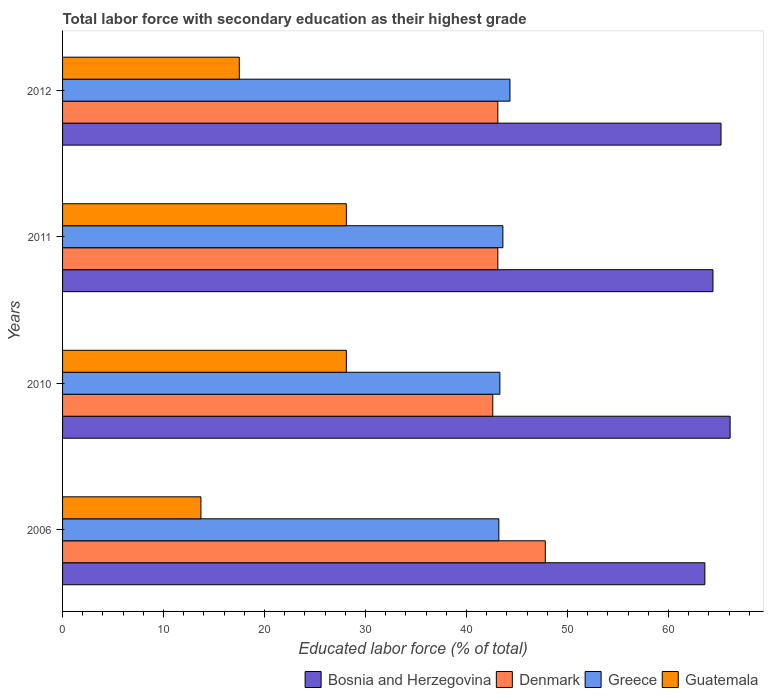How many different coloured bars are there?
Offer a very short reply. 4. How many groups of bars are there?
Offer a terse response. 4. Are the number of bars on each tick of the Y-axis equal?
Your answer should be very brief. Yes. How many bars are there on the 4th tick from the top?
Keep it short and to the point. 4. What is the label of the 4th group of bars from the top?
Make the answer very short. 2006. In how many cases, is the number of bars for a given year not equal to the number of legend labels?
Offer a very short reply. 0. What is the percentage of total labor force with primary education in Denmark in 2006?
Make the answer very short. 47.8. Across all years, what is the maximum percentage of total labor force with primary education in Bosnia and Herzegovina?
Your answer should be compact. 66.1. Across all years, what is the minimum percentage of total labor force with primary education in Denmark?
Give a very brief answer. 42.6. What is the total percentage of total labor force with primary education in Bosnia and Herzegovina in the graph?
Your answer should be very brief. 259.3. What is the difference between the percentage of total labor force with primary education in Greece in 2010 and that in 2012?
Make the answer very short. -1. What is the difference between the percentage of total labor force with primary education in Bosnia and Herzegovina in 2011 and the percentage of total labor force with primary education in Greece in 2012?
Give a very brief answer. 20.1. What is the average percentage of total labor force with primary education in Greece per year?
Your response must be concise. 43.6. In the year 2011, what is the difference between the percentage of total labor force with primary education in Denmark and percentage of total labor force with primary education in Bosnia and Herzegovina?
Provide a short and direct response. -21.3. In how many years, is the percentage of total labor force with primary education in Denmark greater than 10 %?
Your answer should be compact. 4. What is the ratio of the percentage of total labor force with primary education in Denmark in 2006 to that in 2011?
Your response must be concise. 1.11. Is the difference between the percentage of total labor force with primary education in Denmark in 2006 and 2012 greater than the difference between the percentage of total labor force with primary education in Bosnia and Herzegovina in 2006 and 2012?
Provide a short and direct response. Yes. What is the difference between the highest and the lowest percentage of total labor force with primary education in Bosnia and Herzegovina?
Offer a terse response. 2.5. Is the sum of the percentage of total labor force with primary education in Denmark in 2006 and 2010 greater than the maximum percentage of total labor force with primary education in Greece across all years?
Give a very brief answer. Yes. Is it the case that in every year, the sum of the percentage of total labor force with primary education in Guatemala and percentage of total labor force with primary education in Bosnia and Herzegovina is greater than the sum of percentage of total labor force with primary education in Denmark and percentage of total labor force with primary education in Greece?
Offer a very short reply. No. What does the 3rd bar from the top in 2006 represents?
Ensure brevity in your answer.  Denmark. What does the 3rd bar from the bottom in 2006 represents?
Ensure brevity in your answer.  Greece. What is the difference between two consecutive major ticks on the X-axis?
Make the answer very short. 10. Are the values on the major ticks of X-axis written in scientific E-notation?
Provide a succinct answer. No. Does the graph contain any zero values?
Give a very brief answer. No. How many legend labels are there?
Your response must be concise. 4. How are the legend labels stacked?
Make the answer very short. Horizontal. What is the title of the graph?
Make the answer very short. Total labor force with secondary education as their highest grade. Does "Nepal" appear as one of the legend labels in the graph?
Your answer should be compact. No. What is the label or title of the X-axis?
Provide a short and direct response. Educated labor force (% of total). What is the label or title of the Y-axis?
Your answer should be very brief. Years. What is the Educated labor force (% of total) in Bosnia and Herzegovina in 2006?
Give a very brief answer. 63.6. What is the Educated labor force (% of total) in Denmark in 2006?
Offer a very short reply. 47.8. What is the Educated labor force (% of total) of Greece in 2006?
Offer a very short reply. 43.2. What is the Educated labor force (% of total) in Guatemala in 2006?
Give a very brief answer. 13.7. What is the Educated labor force (% of total) of Bosnia and Herzegovina in 2010?
Offer a very short reply. 66.1. What is the Educated labor force (% of total) in Denmark in 2010?
Provide a short and direct response. 42.6. What is the Educated labor force (% of total) in Greece in 2010?
Make the answer very short. 43.3. What is the Educated labor force (% of total) of Guatemala in 2010?
Offer a terse response. 28.1. What is the Educated labor force (% of total) of Bosnia and Herzegovina in 2011?
Your response must be concise. 64.4. What is the Educated labor force (% of total) in Denmark in 2011?
Make the answer very short. 43.1. What is the Educated labor force (% of total) in Greece in 2011?
Your response must be concise. 43.6. What is the Educated labor force (% of total) in Guatemala in 2011?
Make the answer very short. 28.1. What is the Educated labor force (% of total) of Bosnia and Herzegovina in 2012?
Ensure brevity in your answer.  65.2. What is the Educated labor force (% of total) in Denmark in 2012?
Keep it short and to the point. 43.1. What is the Educated labor force (% of total) of Greece in 2012?
Make the answer very short. 44.3. Across all years, what is the maximum Educated labor force (% of total) of Bosnia and Herzegovina?
Make the answer very short. 66.1. Across all years, what is the maximum Educated labor force (% of total) of Denmark?
Your answer should be compact. 47.8. Across all years, what is the maximum Educated labor force (% of total) of Greece?
Offer a terse response. 44.3. Across all years, what is the maximum Educated labor force (% of total) of Guatemala?
Provide a succinct answer. 28.1. Across all years, what is the minimum Educated labor force (% of total) of Bosnia and Herzegovina?
Your response must be concise. 63.6. Across all years, what is the minimum Educated labor force (% of total) of Denmark?
Offer a very short reply. 42.6. Across all years, what is the minimum Educated labor force (% of total) of Greece?
Give a very brief answer. 43.2. Across all years, what is the minimum Educated labor force (% of total) in Guatemala?
Offer a terse response. 13.7. What is the total Educated labor force (% of total) in Bosnia and Herzegovina in the graph?
Keep it short and to the point. 259.3. What is the total Educated labor force (% of total) in Denmark in the graph?
Offer a terse response. 176.6. What is the total Educated labor force (% of total) in Greece in the graph?
Provide a succinct answer. 174.4. What is the total Educated labor force (% of total) in Guatemala in the graph?
Make the answer very short. 87.4. What is the difference between the Educated labor force (% of total) of Bosnia and Herzegovina in 2006 and that in 2010?
Your response must be concise. -2.5. What is the difference between the Educated labor force (% of total) of Greece in 2006 and that in 2010?
Provide a short and direct response. -0.1. What is the difference between the Educated labor force (% of total) in Guatemala in 2006 and that in 2010?
Make the answer very short. -14.4. What is the difference between the Educated labor force (% of total) in Denmark in 2006 and that in 2011?
Ensure brevity in your answer.  4.7. What is the difference between the Educated labor force (% of total) of Greece in 2006 and that in 2011?
Your answer should be compact. -0.4. What is the difference between the Educated labor force (% of total) in Guatemala in 2006 and that in 2011?
Provide a short and direct response. -14.4. What is the difference between the Educated labor force (% of total) in Greece in 2006 and that in 2012?
Your answer should be compact. -1.1. What is the difference between the Educated labor force (% of total) of Bosnia and Herzegovina in 2010 and that in 2011?
Offer a very short reply. 1.7. What is the difference between the Educated labor force (% of total) in Denmark in 2010 and that in 2011?
Provide a succinct answer. -0.5. What is the difference between the Educated labor force (% of total) in Bosnia and Herzegovina in 2010 and that in 2012?
Keep it short and to the point. 0.9. What is the difference between the Educated labor force (% of total) in Denmark in 2010 and that in 2012?
Make the answer very short. -0.5. What is the difference between the Educated labor force (% of total) of Guatemala in 2011 and that in 2012?
Your answer should be compact. 10.6. What is the difference between the Educated labor force (% of total) of Bosnia and Herzegovina in 2006 and the Educated labor force (% of total) of Greece in 2010?
Offer a very short reply. 20.3. What is the difference between the Educated labor force (% of total) of Bosnia and Herzegovina in 2006 and the Educated labor force (% of total) of Guatemala in 2010?
Ensure brevity in your answer.  35.5. What is the difference between the Educated labor force (% of total) in Denmark in 2006 and the Educated labor force (% of total) in Greece in 2010?
Give a very brief answer. 4.5. What is the difference between the Educated labor force (% of total) in Denmark in 2006 and the Educated labor force (% of total) in Guatemala in 2010?
Give a very brief answer. 19.7. What is the difference between the Educated labor force (% of total) of Greece in 2006 and the Educated labor force (% of total) of Guatemala in 2010?
Your answer should be very brief. 15.1. What is the difference between the Educated labor force (% of total) of Bosnia and Herzegovina in 2006 and the Educated labor force (% of total) of Denmark in 2011?
Your answer should be compact. 20.5. What is the difference between the Educated labor force (% of total) of Bosnia and Herzegovina in 2006 and the Educated labor force (% of total) of Guatemala in 2011?
Your answer should be compact. 35.5. What is the difference between the Educated labor force (% of total) of Bosnia and Herzegovina in 2006 and the Educated labor force (% of total) of Denmark in 2012?
Offer a terse response. 20.5. What is the difference between the Educated labor force (% of total) of Bosnia and Herzegovina in 2006 and the Educated labor force (% of total) of Greece in 2012?
Keep it short and to the point. 19.3. What is the difference between the Educated labor force (% of total) in Bosnia and Herzegovina in 2006 and the Educated labor force (% of total) in Guatemala in 2012?
Provide a short and direct response. 46.1. What is the difference between the Educated labor force (% of total) in Denmark in 2006 and the Educated labor force (% of total) in Greece in 2012?
Make the answer very short. 3.5. What is the difference between the Educated labor force (% of total) of Denmark in 2006 and the Educated labor force (% of total) of Guatemala in 2012?
Make the answer very short. 30.3. What is the difference between the Educated labor force (% of total) in Greece in 2006 and the Educated labor force (% of total) in Guatemala in 2012?
Keep it short and to the point. 25.7. What is the difference between the Educated labor force (% of total) in Bosnia and Herzegovina in 2010 and the Educated labor force (% of total) in Denmark in 2011?
Provide a succinct answer. 23. What is the difference between the Educated labor force (% of total) of Bosnia and Herzegovina in 2010 and the Educated labor force (% of total) of Greece in 2011?
Provide a succinct answer. 22.5. What is the difference between the Educated labor force (% of total) of Bosnia and Herzegovina in 2010 and the Educated labor force (% of total) of Greece in 2012?
Your answer should be very brief. 21.8. What is the difference between the Educated labor force (% of total) in Bosnia and Herzegovina in 2010 and the Educated labor force (% of total) in Guatemala in 2012?
Provide a short and direct response. 48.6. What is the difference between the Educated labor force (% of total) in Denmark in 2010 and the Educated labor force (% of total) in Greece in 2012?
Your answer should be very brief. -1.7. What is the difference between the Educated labor force (% of total) of Denmark in 2010 and the Educated labor force (% of total) of Guatemala in 2012?
Keep it short and to the point. 25.1. What is the difference between the Educated labor force (% of total) in Greece in 2010 and the Educated labor force (% of total) in Guatemala in 2012?
Offer a very short reply. 25.8. What is the difference between the Educated labor force (% of total) of Bosnia and Herzegovina in 2011 and the Educated labor force (% of total) of Denmark in 2012?
Provide a short and direct response. 21.3. What is the difference between the Educated labor force (% of total) of Bosnia and Herzegovina in 2011 and the Educated labor force (% of total) of Greece in 2012?
Give a very brief answer. 20.1. What is the difference between the Educated labor force (% of total) in Bosnia and Herzegovina in 2011 and the Educated labor force (% of total) in Guatemala in 2012?
Make the answer very short. 46.9. What is the difference between the Educated labor force (% of total) in Denmark in 2011 and the Educated labor force (% of total) in Greece in 2012?
Keep it short and to the point. -1.2. What is the difference between the Educated labor force (% of total) of Denmark in 2011 and the Educated labor force (% of total) of Guatemala in 2012?
Make the answer very short. 25.6. What is the difference between the Educated labor force (% of total) of Greece in 2011 and the Educated labor force (% of total) of Guatemala in 2012?
Offer a terse response. 26.1. What is the average Educated labor force (% of total) in Bosnia and Herzegovina per year?
Ensure brevity in your answer.  64.83. What is the average Educated labor force (% of total) of Denmark per year?
Provide a succinct answer. 44.15. What is the average Educated labor force (% of total) in Greece per year?
Provide a succinct answer. 43.6. What is the average Educated labor force (% of total) in Guatemala per year?
Ensure brevity in your answer.  21.85. In the year 2006, what is the difference between the Educated labor force (% of total) of Bosnia and Herzegovina and Educated labor force (% of total) of Denmark?
Give a very brief answer. 15.8. In the year 2006, what is the difference between the Educated labor force (% of total) of Bosnia and Herzegovina and Educated labor force (% of total) of Greece?
Keep it short and to the point. 20.4. In the year 2006, what is the difference between the Educated labor force (% of total) of Bosnia and Herzegovina and Educated labor force (% of total) of Guatemala?
Give a very brief answer. 49.9. In the year 2006, what is the difference between the Educated labor force (% of total) in Denmark and Educated labor force (% of total) in Guatemala?
Make the answer very short. 34.1. In the year 2006, what is the difference between the Educated labor force (% of total) in Greece and Educated labor force (% of total) in Guatemala?
Ensure brevity in your answer.  29.5. In the year 2010, what is the difference between the Educated labor force (% of total) of Bosnia and Herzegovina and Educated labor force (% of total) of Greece?
Provide a short and direct response. 22.8. In the year 2010, what is the difference between the Educated labor force (% of total) of Bosnia and Herzegovina and Educated labor force (% of total) of Guatemala?
Keep it short and to the point. 38. In the year 2010, what is the difference between the Educated labor force (% of total) of Denmark and Educated labor force (% of total) of Greece?
Keep it short and to the point. -0.7. In the year 2010, what is the difference between the Educated labor force (% of total) in Greece and Educated labor force (% of total) in Guatemala?
Provide a short and direct response. 15.2. In the year 2011, what is the difference between the Educated labor force (% of total) of Bosnia and Herzegovina and Educated labor force (% of total) of Denmark?
Your answer should be compact. 21.3. In the year 2011, what is the difference between the Educated labor force (% of total) of Bosnia and Herzegovina and Educated labor force (% of total) of Greece?
Give a very brief answer. 20.8. In the year 2011, what is the difference between the Educated labor force (% of total) in Bosnia and Herzegovina and Educated labor force (% of total) in Guatemala?
Your answer should be compact. 36.3. In the year 2012, what is the difference between the Educated labor force (% of total) of Bosnia and Herzegovina and Educated labor force (% of total) of Denmark?
Ensure brevity in your answer.  22.1. In the year 2012, what is the difference between the Educated labor force (% of total) of Bosnia and Herzegovina and Educated labor force (% of total) of Greece?
Keep it short and to the point. 20.9. In the year 2012, what is the difference between the Educated labor force (% of total) in Bosnia and Herzegovina and Educated labor force (% of total) in Guatemala?
Your answer should be very brief. 47.7. In the year 2012, what is the difference between the Educated labor force (% of total) of Denmark and Educated labor force (% of total) of Greece?
Your answer should be very brief. -1.2. In the year 2012, what is the difference between the Educated labor force (% of total) in Denmark and Educated labor force (% of total) in Guatemala?
Provide a succinct answer. 25.6. In the year 2012, what is the difference between the Educated labor force (% of total) in Greece and Educated labor force (% of total) in Guatemala?
Give a very brief answer. 26.8. What is the ratio of the Educated labor force (% of total) in Bosnia and Herzegovina in 2006 to that in 2010?
Give a very brief answer. 0.96. What is the ratio of the Educated labor force (% of total) of Denmark in 2006 to that in 2010?
Ensure brevity in your answer.  1.12. What is the ratio of the Educated labor force (% of total) of Greece in 2006 to that in 2010?
Your answer should be very brief. 1. What is the ratio of the Educated labor force (% of total) in Guatemala in 2006 to that in 2010?
Give a very brief answer. 0.49. What is the ratio of the Educated labor force (% of total) in Bosnia and Herzegovina in 2006 to that in 2011?
Your answer should be very brief. 0.99. What is the ratio of the Educated labor force (% of total) in Denmark in 2006 to that in 2011?
Offer a terse response. 1.11. What is the ratio of the Educated labor force (% of total) in Guatemala in 2006 to that in 2011?
Provide a succinct answer. 0.49. What is the ratio of the Educated labor force (% of total) in Bosnia and Herzegovina in 2006 to that in 2012?
Offer a terse response. 0.98. What is the ratio of the Educated labor force (% of total) in Denmark in 2006 to that in 2012?
Your answer should be very brief. 1.11. What is the ratio of the Educated labor force (% of total) in Greece in 2006 to that in 2012?
Provide a succinct answer. 0.98. What is the ratio of the Educated labor force (% of total) in Guatemala in 2006 to that in 2012?
Offer a terse response. 0.78. What is the ratio of the Educated labor force (% of total) in Bosnia and Herzegovina in 2010 to that in 2011?
Offer a very short reply. 1.03. What is the ratio of the Educated labor force (% of total) of Denmark in 2010 to that in 2011?
Your response must be concise. 0.99. What is the ratio of the Educated labor force (% of total) of Greece in 2010 to that in 2011?
Your response must be concise. 0.99. What is the ratio of the Educated labor force (% of total) in Bosnia and Herzegovina in 2010 to that in 2012?
Make the answer very short. 1.01. What is the ratio of the Educated labor force (% of total) in Denmark in 2010 to that in 2012?
Provide a succinct answer. 0.99. What is the ratio of the Educated labor force (% of total) of Greece in 2010 to that in 2012?
Your response must be concise. 0.98. What is the ratio of the Educated labor force (% of total) of Guatemala in 2010 to that in 2012?
Offer a terse response. 1.61. What is the ratio of the Educated labor force (% of total) of Greece in 2011 to that in 2012?
Offer a terse response. 0.98. What is the ratio of the Educated labor force (% of total) in Guatemala in 2011 to that in 2012?
Give a very brief answer. 1.61. What is the difference between the highest and the second highest Educated labor force (% of total) in Denmark?
Ensure brevity in your answer.  4.7. What is the difference between the highest and the second highest Educated labor force (% of total) of Greece?
Your response must be concise. 0.7. What is the difference between the highest and the second highest Educated labor force (% of total) of Guatemala?
Keep it short and to the point. 0. What is the difference between the highest and the lowest Educated labor force (% of total) of Guatemala?
Your answer should be very brief. 14.4. 